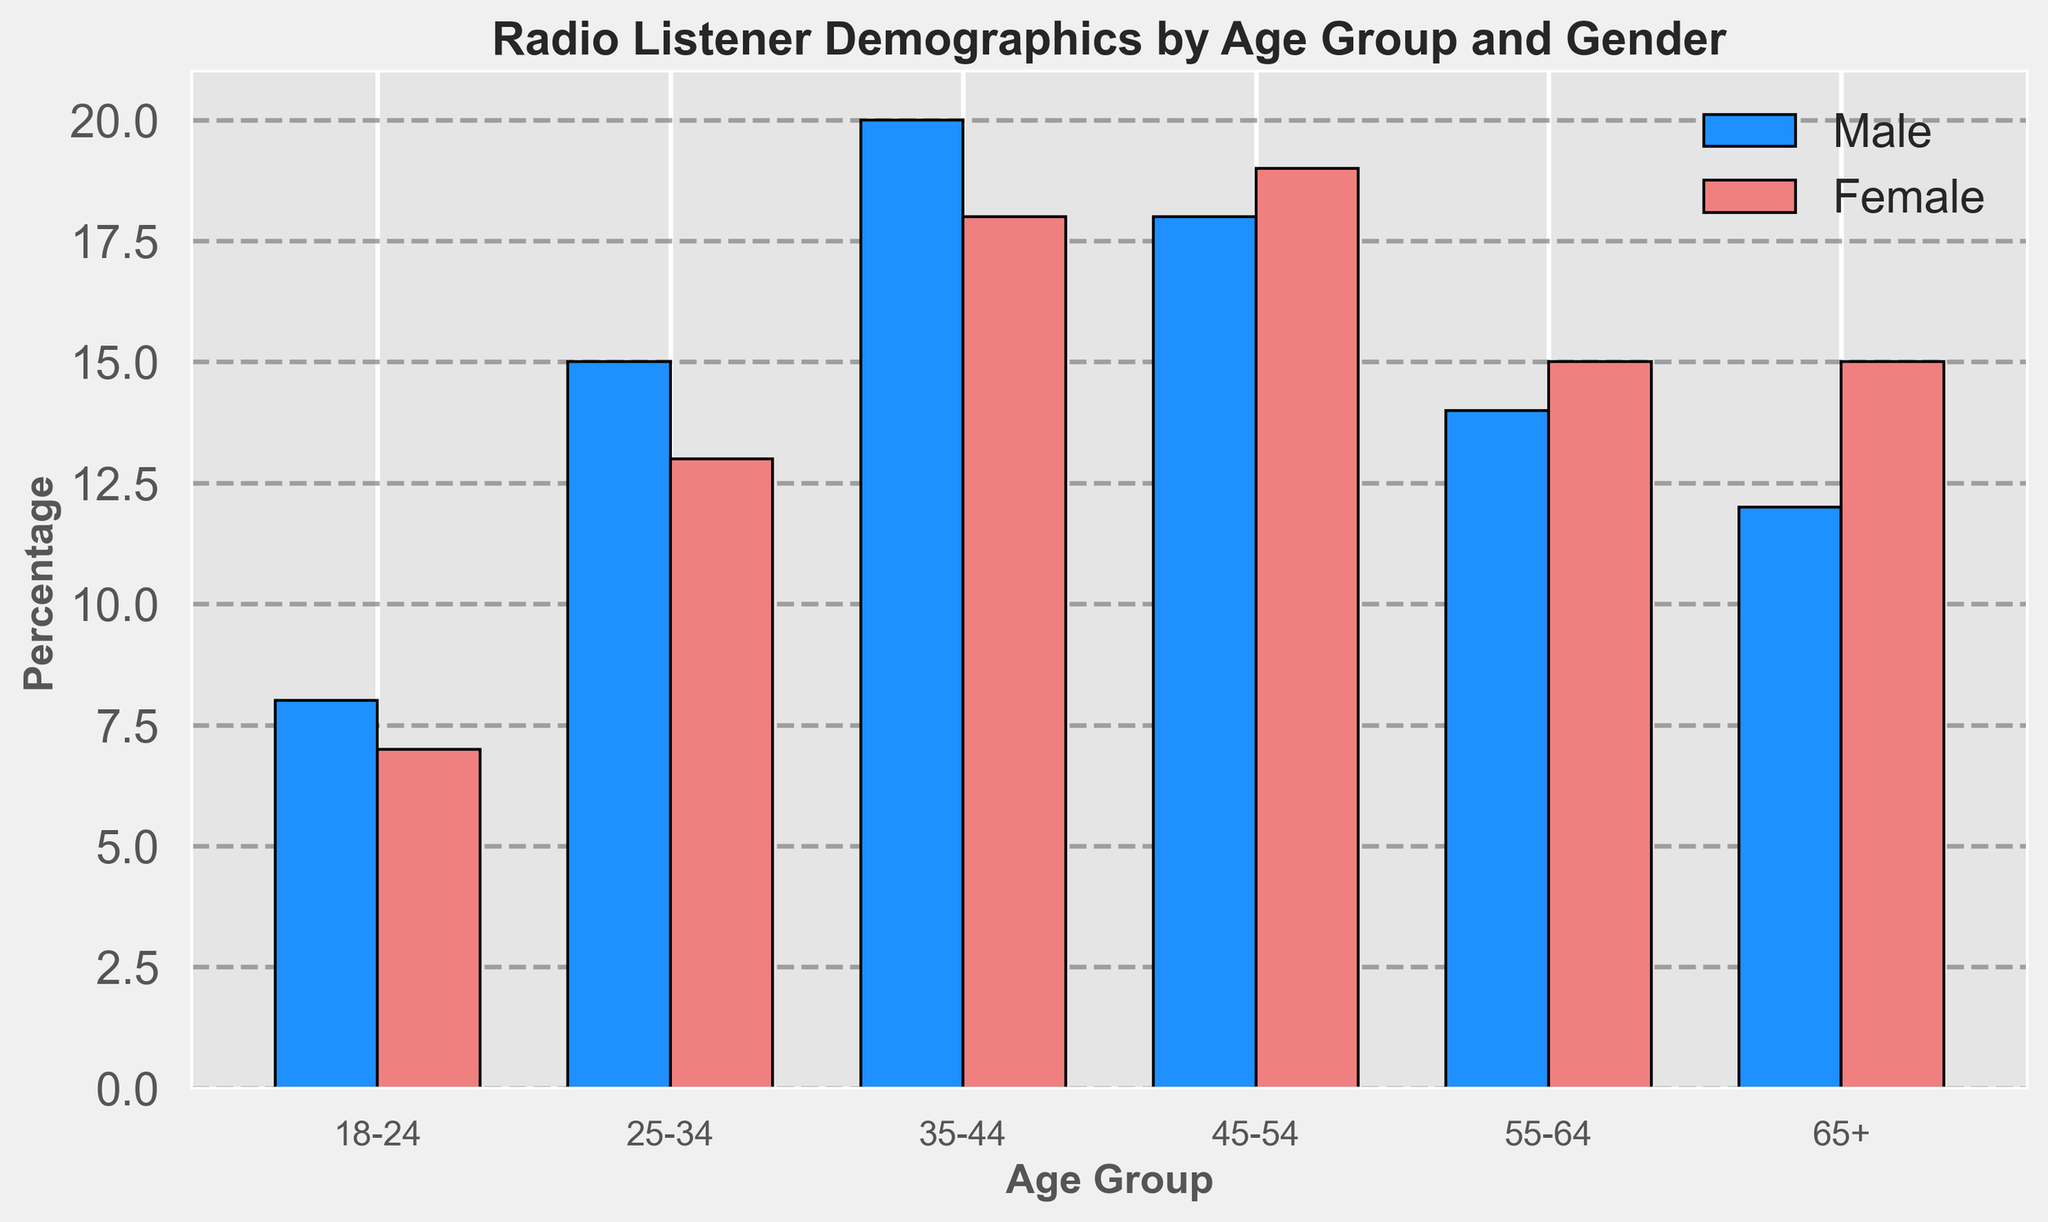What's the highest percentage of radio listeners in any age group for females? Examine the bar heights for all female age groups, finding 19% for the 45-54 age group as the tallest.
Answer: 19% Which gender has more listeners in the 18-24 age group? Compare the bar heights for males and females in the 18-24 age group. The bar for males is slightly taller (8%) compared to females (7%).
Answer: Male What’s the difference in percentage between male and female listeners in the 35-44 age group? Check the bar heights for both genders in the 35-44 age group: 20% for males and 18% for females, leading to a difference of 2%.
Answer: 2% Which age group has the smallest difference in percentage between male and female listeners? Look at the differences between bars for each age group. For the 65+ age group, both have the smallest difference of 3% (Male: 12%, Female: 15%).
Answer: 65+ In which age group do males have the highest percentage of listeners? Compare bar heights for males across all age groups, finding the tallest at 35-44 (20%).
Answer: 35-44 What’s the average percentage of female listeners across all age groups? Add percentages for females: 7 + 13 + 18 + 19 + 15 + 15 = 87; then, divide by the number of age groups (6). 87/6 = 14.5.
Answer: 14.5 Which age group has the closest percentage of listeners between genders? Determine the differences between genders in each age group, identifying 55-64 with the smallest difference (Male: 14%, Female: 15%, difference: 1%).
Answer: 55-64 How many age groups have a higher percentage of female listeners than male listeners? Compare the bar heights for each age group, finding female listener percentages higher in 45-54 and 65+ age groups.
Answer: 2 What’s the total percentage of listeners aged 25-34? Add percentages for both genders in the 25-34 age group (Male: 15%, Female: 13%), getting a total of 28%.
Answer: 28% Which age group has the fewest male listeners? Look at the shortest bar for males, which is in the 18-24 age group (8%).
Answer: 18-24 